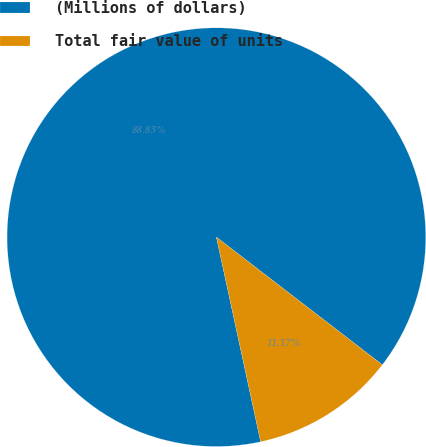<chart> <loc_0><loc_0><loc_500><loc_500><pie_chart><fcel>(Millions of dollars)<fcel>Total fair value of units<nl><fcel>88.83%<fcel>11.17%<nl></chart> 